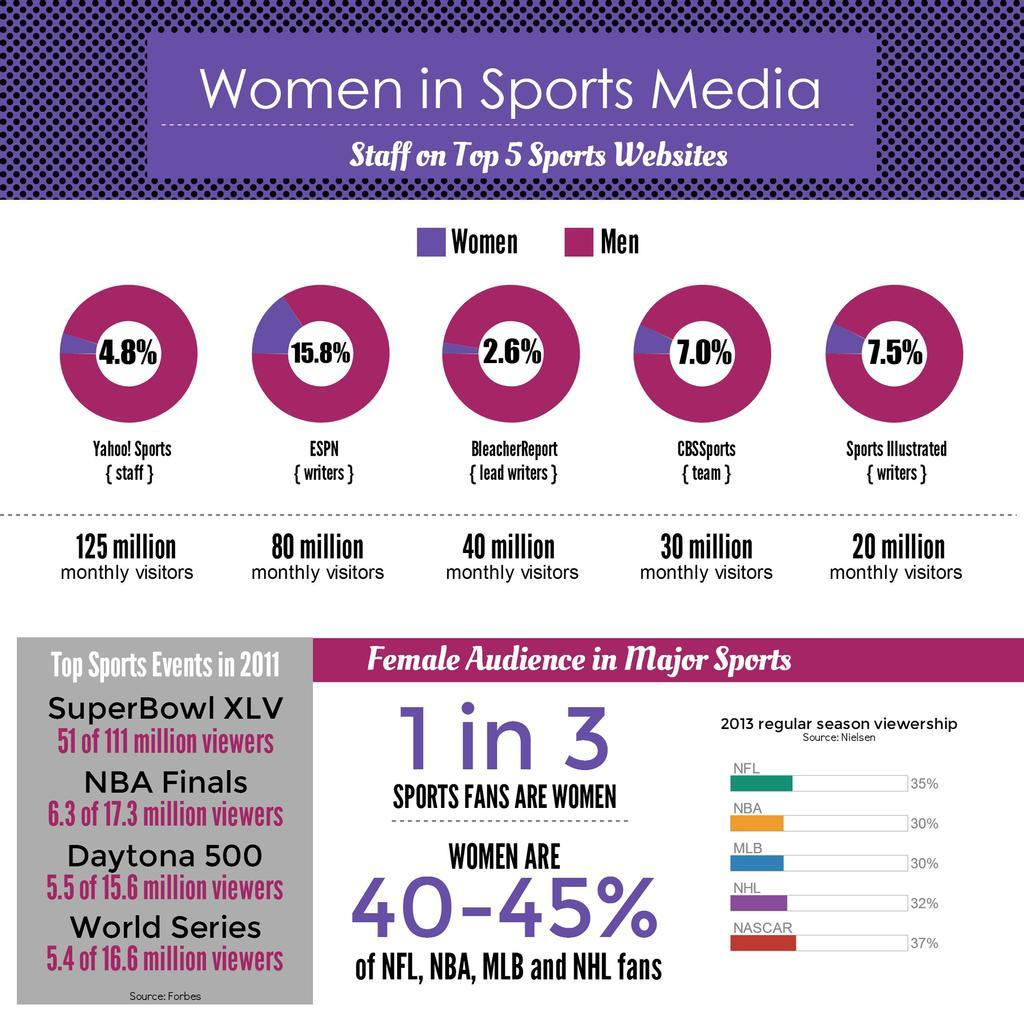Mention a couple of crucial points in this snapshot. According to a recent survey, women working as writers at ESPN make up 15.8% of the workforce. In contrast, only 2.6% of women work as writers at ESPN. Additionally, another 7.5% of women are employed as writers at the network. These figures suggest that there is significant room for improvement in terms of gender representation in the writing industry at ESPN. It is estimated that 97.4% of lead writers at BleacherReport are men. 